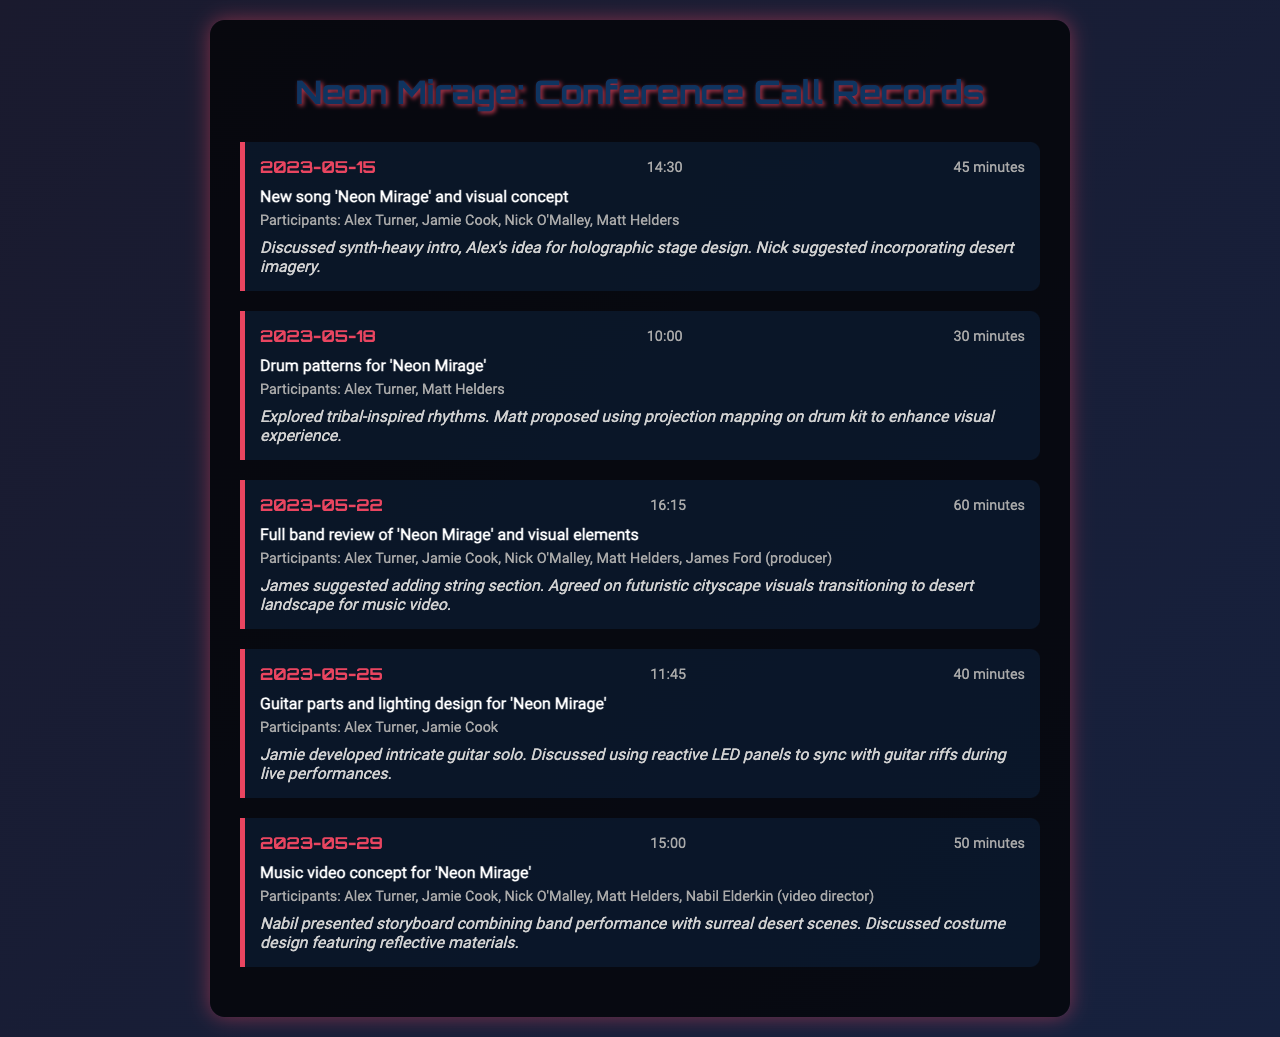What is the date of the first conference call? The document lists the calls in chronological order, with the first call occurring on May 15, 2023.
Answer: 2023-05-15 Who proposed the use of projection mapping on the drum kit? The call notes state that Matt suggested using projection mapping for visual enhancement during the call on May 18, 2023.
Answer: Matt Helders What is the main subject of the call on May 22, 2023? The document specifies that the main subject of the call on this date was the full band review of 'Neon Mirage' and its visual elements.
Answer: Full band review of 'Neon Mirage' and visual elements How long did the call on May 29, 2023, last? The document indicates that the duration of the call on this date was 50 minutes.
Answer: 50 minutes What is the theme of the video concept presented by Nabil Elderkin? The call notes for May 29, 2023, state the theme combines band performance with surreal desert scenes, reflecting Nabil's storyboard presentation.
Answer: Surreal desert scenes Which participant suggested adding a string section? During the call on May 22, 2023, James Ford suggested the addition of a string section to the composition.
Answer: James Ford What visual elements were discussed for the live performances? The call on May 25, 2023, mentioned the use of reactive LED panels to sync with guitar riffs as visual elements for live performances.
Answer: Reactive LED panels How many participants were in the call on May 22, 2023? The document lists five participants from the call on this date, which includes Alex Turner, Jamie Cook, Nick O'Malley, Matt Helders, and James Ford.
Answer: Five What was Alex's idea regarding the stage design? The notes from the first call suggest that Alex proposed a holographic stage design as part of the visual concept for 'Neon Mirage'.
Answer: Holographic stage design 